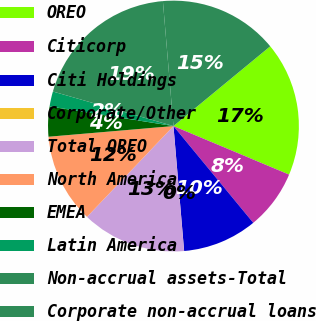<chart> <loc_0><loc_0><loc_500><loc_500><pie_chart><fcel>OREO<fcel>Citicorp<fcel>Citi Holdings<fcel>Corporate/Other<fcel>Total OREO<fcel>North America<fcel>EMEA<fcel>Latin America<fcel>Non-accrual assets-Total<fcel>Corporate non-accrual loans<nl><fcel>17.3%<fcel>7.7%<fcel>9.62%<fcel>0.01%<fcel>13.46%<fcel>11.54%<fcel>3.86%<fcel>1.94%<fcel>19.22%<fcel>15.38%<nl></chart> 